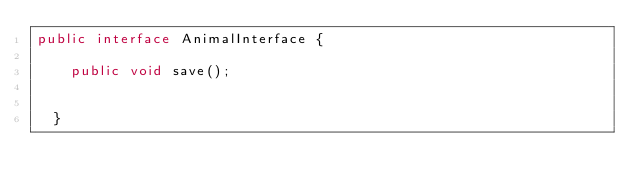Convert code to text. <code><loc_0><loc_0><loc_500><loc_500><_Java_>public interface AnimalInterface {

    public void save();
  
  
  }</code> 